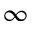<formula> <loc_0><loc_0><loc_500><loc_500>\infty</formula> 